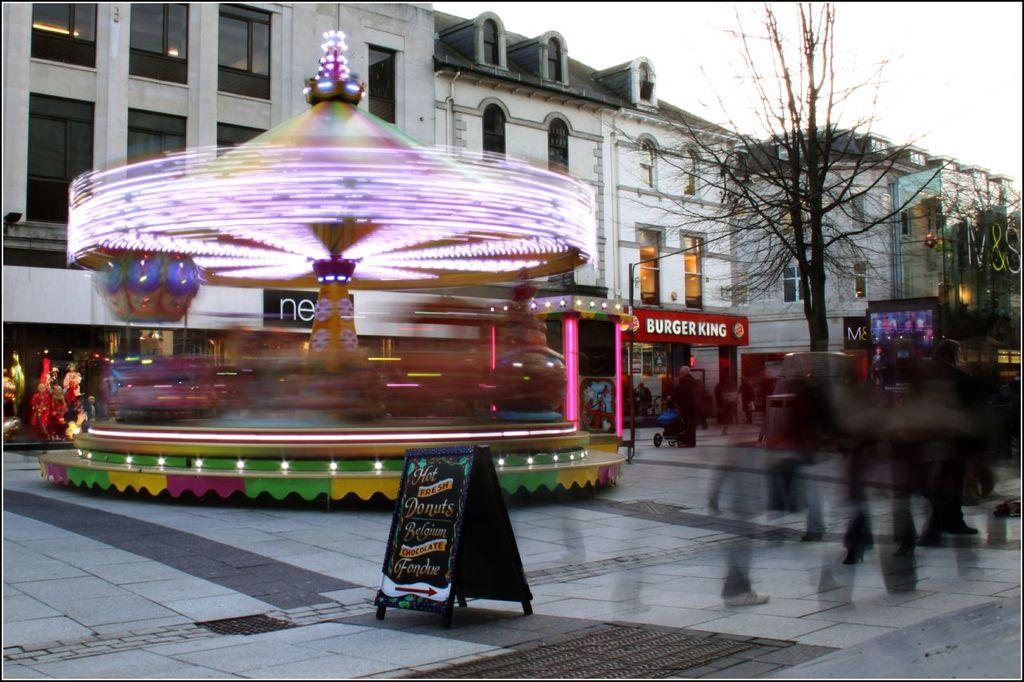<image>
Render a clear and concise summary of the photo. A spinning lit up carousel goes around in front of a number of businesses including a Burger King. 